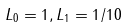Convert formula to latex. <formula><loc_0><loc_0><loc_500><loc_500>L _ { 0 } = 1 , L _ { 1 } = 1 / 1 0</formula> 